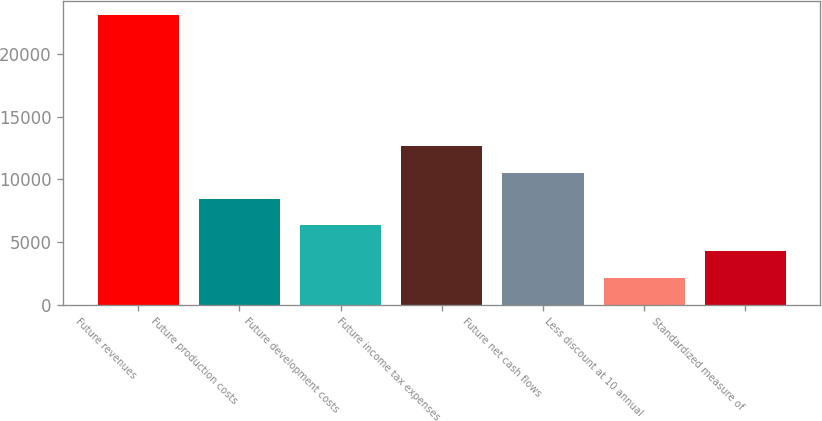Convert chart to OTSL. <chart><loc_0><loc_0><loc_500><loc_500><bar_chart><fcel>Future revenues<fcel>Future production costs<fcel>Future development costs<fcel>Future income tax expenses<fcel>Future net cash flows<fcel>Less discount at 10 annual<fcel>Standardized measure of<nl><fcel>23115<fcel>8443.7<fcel>6347.8<fcel>12635.5<fcel>10539.6<fcel>2156<fcel>4251.9<nl></chart> 